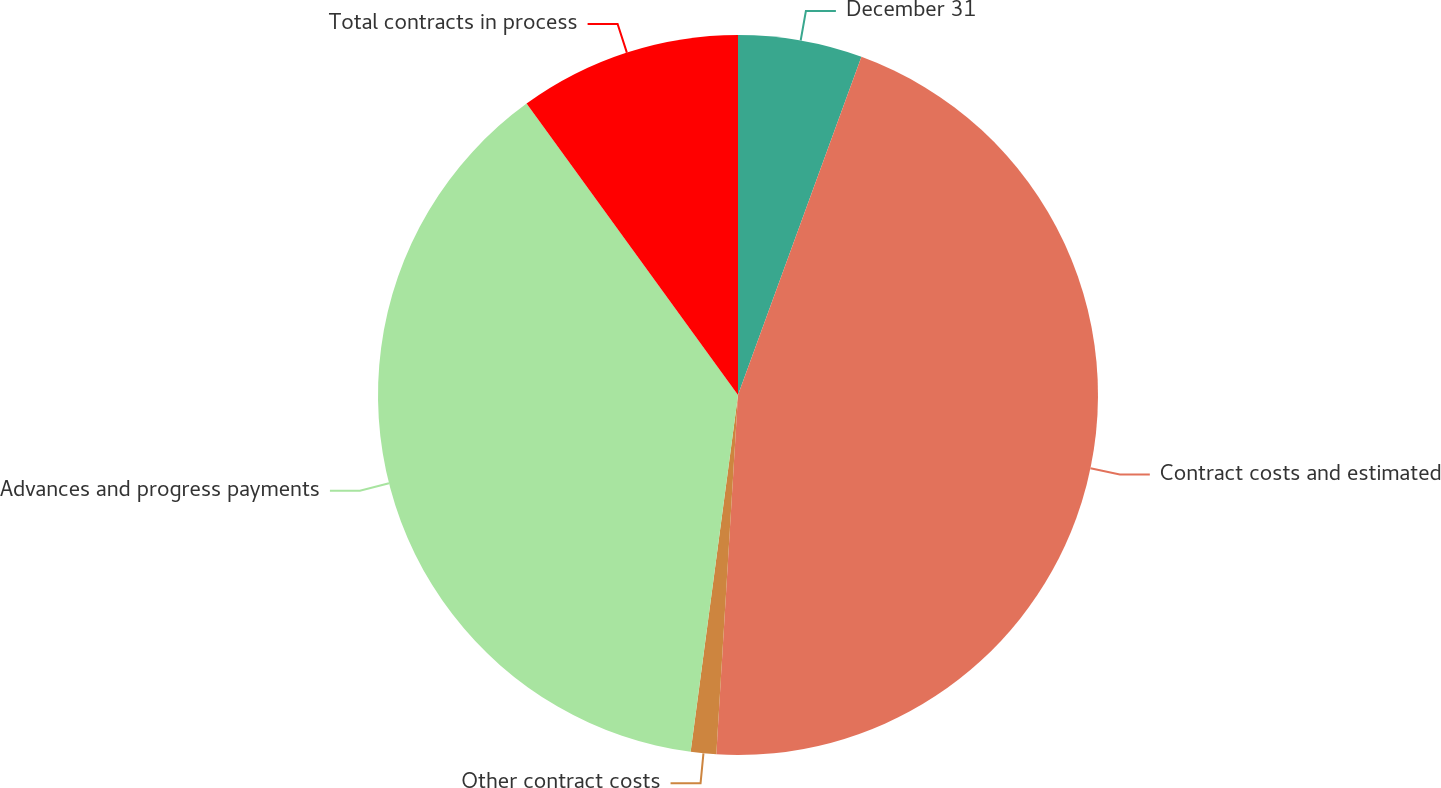<chart> <loc_0><loc_0><loc_500><loc_500><pie_chart><fcel>December 31<fcel>Contract costs and estimated<fcel>Other contract costs<fcel>Advances and progress payments<fcel>Total contracts in process<nl><fcel>5.57%<fcel>45.39%<fcel>1.14%<fcel>37.91%<fcel>9.99%<nl></chart> 